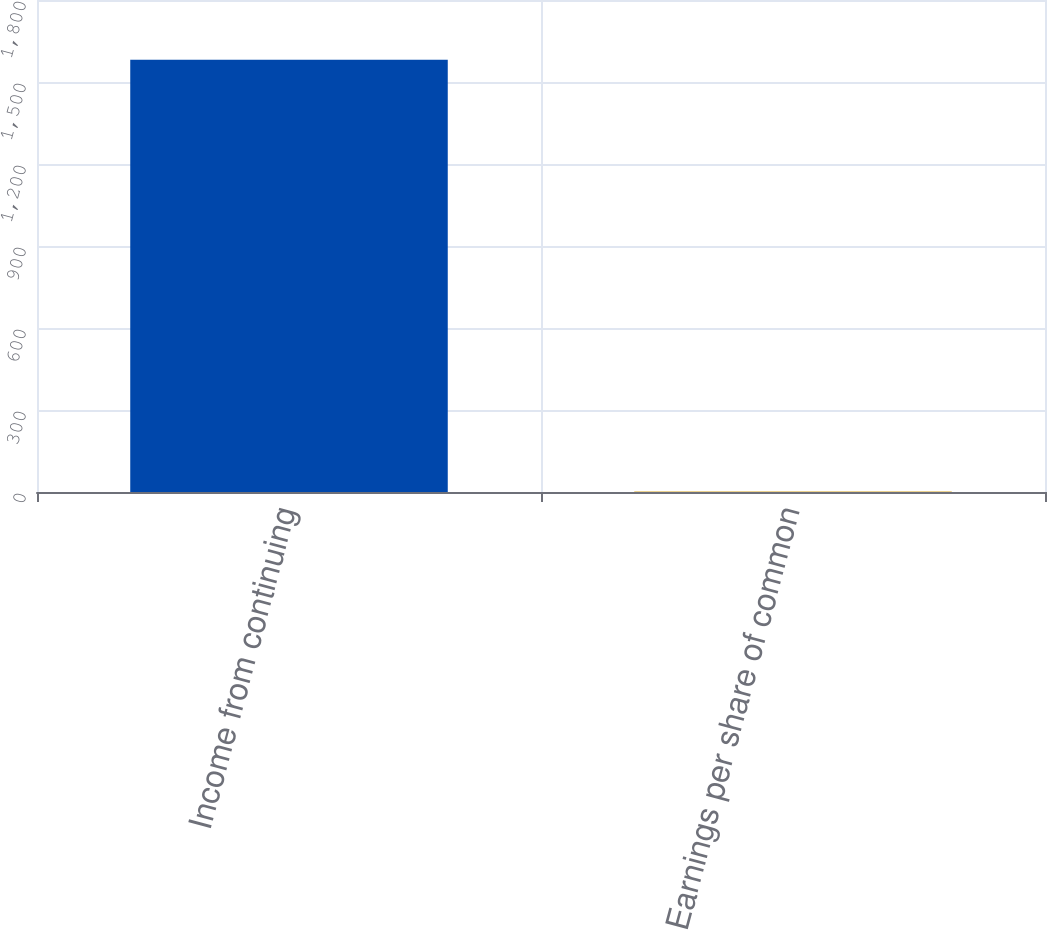Convert chart. <chart><loc_0><loc_0><loc_500><loc_500><bar_chart><fcel>Income from continuing<fcel>Earnings per share of common<nl><fcel>1581<fcel>1.86<nl></chart> 